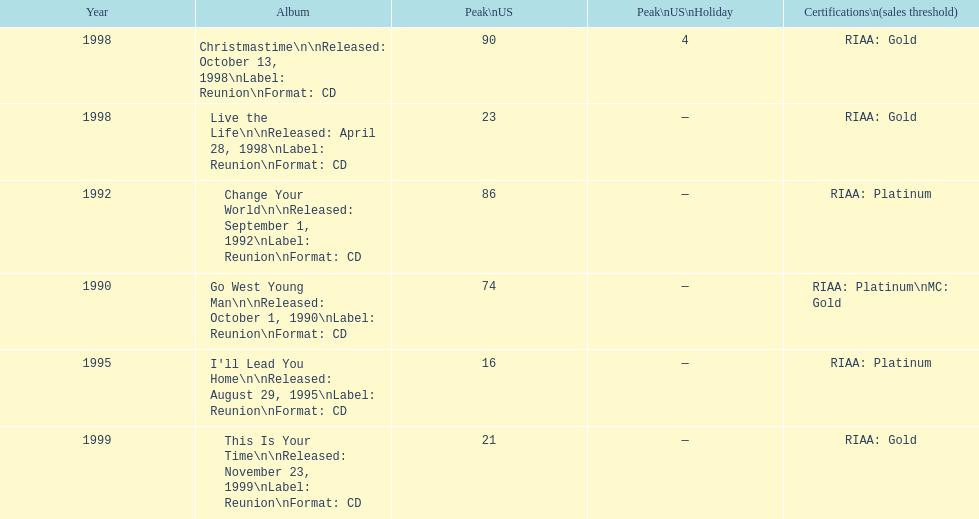How many album entries are there? 6. 